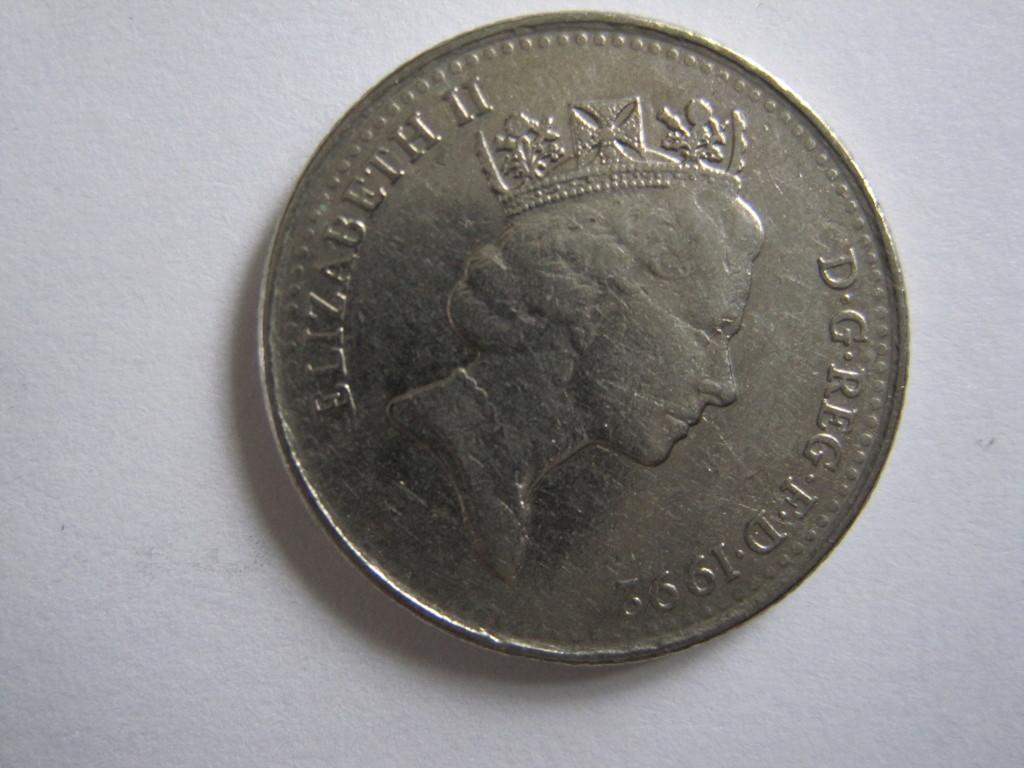What object is the main subject of the image? There is a coin in the image. What is the coin placed on? The coin is placed on a white surface. What type of team is visible in the image? There is no team present in the image; it only features a coin placed on a white surface. 